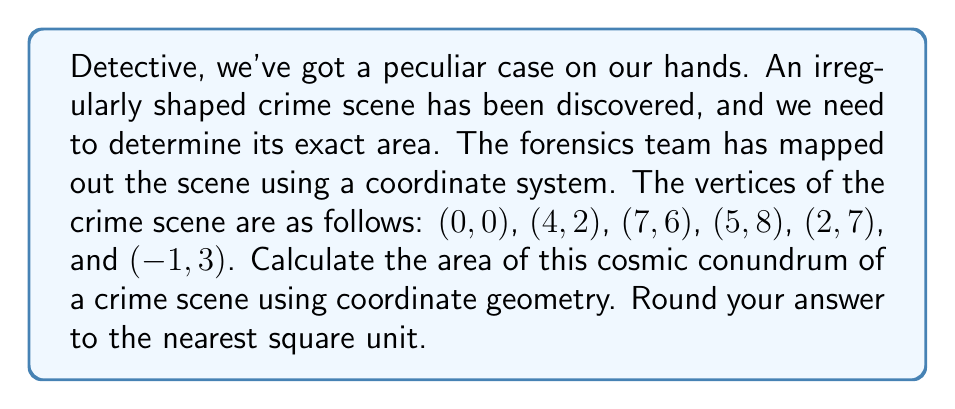Solve this math problem. To solve this cosmic conundrum, we'll use the Shoelace formula (also known as the surveyor's formula) to calculate the area of the irregular polygon formed by the crime scene. Here's how we'll crack this case:

1) The Shoelace formula for a polygon with vertices $(x_1, y_1), (x_2, y_2), ..., (x_n, y_n)$ is:

   $$A = \frac{1}{2}|(x_1y_2 + x_2y_3 + ... + x_ny_1) - (y_1x_2 + y_2x_3 + ... + y_nx_1)|$$

2) Let's organize our data:
   $(x_1, y_1) = (0, 0)$
   $(x_2, y_2) = (4, 2)$
   $(x_3, y_3) = (7, 6)$
   $(x_4, y_4) = (5, 8)$
   $(x_5, y_5) = (2, 7)$
   $(x_6, y_6) = (-1, 3)$

3) Now, let's apply the formula:

   $$A = \frac{1}{2}|[(0 \cdot 2 + 4 \cdot 6 + 7 \cdot 8 + 5 \cdot 7 + 2 \cdot 3 + (-1) \cdot 0) - $$
   $$(0 \cdot 4 + 2 \cdot 7 + 6 \cdot 5 + 8 \cdot 2 + 7 \cdot (-1) + 3 \cdot 0)]|$$

4) Let's solve the expressions inside the parentheses:
   
   $$A = \frac{1}{2}|(0 + 24 + 56 + 35 + 6 + 0) - (0 + 14 + 30 + 16 - 7 + 0)|$$
   
   $$A = \frac{1}{2}|121 - 53|$$

5) Simplify:
   
   $$A = \frac{1}{2}|68| = \frac{68}{2} = 34$$

Therefore, the area of the irregularly shaped crime scene is 34 square units.

[asy]
unitsize(20);
draw((0,0)--(4,2)--(7,6)--(5,8)--(2,7)--(-1,3)--cycle);
dot((0,0));
dot((4,2));
dot((7,6));
dot((5,8));
dot((2,7));
dot((-1,3));
label("(0,0)", (0,0), SW);
label("(4,2)", (4,2), SE);
label("(7,6)", (7,6), E);
label("(5,8)", (5,8), N);
label("(2,7)", (2,7), NW);
label("(-1,3)", (-1,3), W);
[/asy]
Answer: 34 square units 